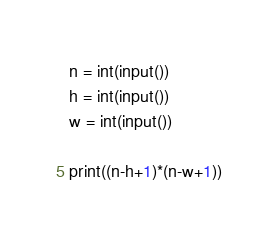<code> <loc_0><loc_0><loc_500><loc_500><_Python_>n = int(input())
h = int(input())
w = int(input())

print((n-h+1)*(n-w+1))</code> 